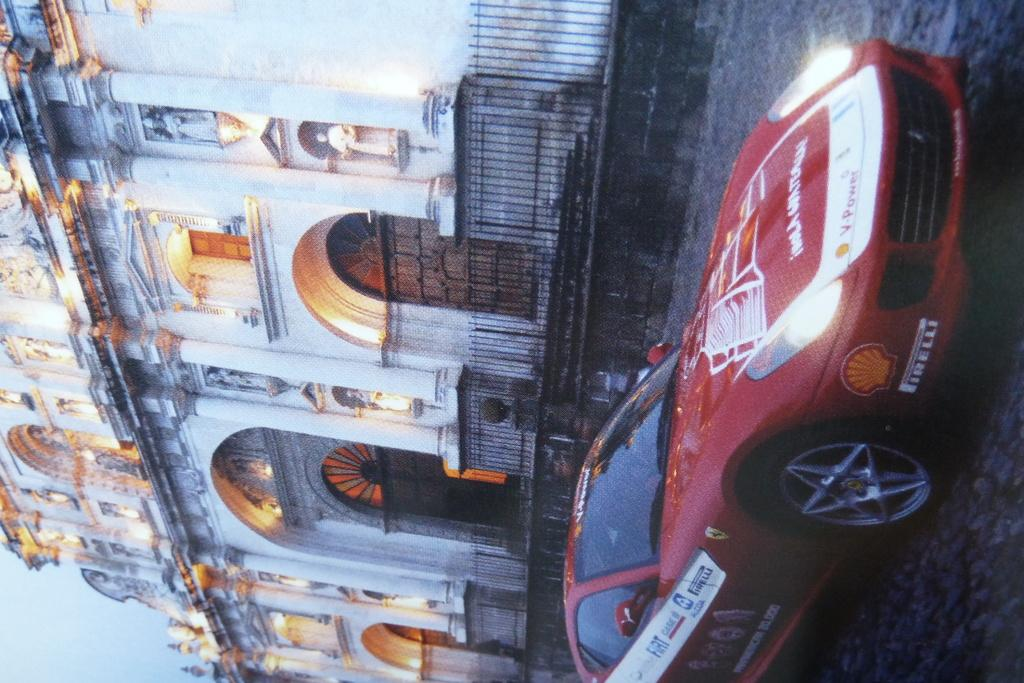What type of structure is present in the image? There is a building in the image. What can be seen illuminated in the image? There are lights visible in the image. What type of artistic objects are in the image? There are statues in the image. What is visible in the background of the image? The sky is visible in the image. What type of transportation is present in the image? There is a vehicle in the image. What type of behavior can be observed in the mouth of the boot in the image? There is no boot or mouth present in the image. How does the behavior of the vehicle change throughout the image? The image is a still image, so the behavior of the vehicle does not change. 